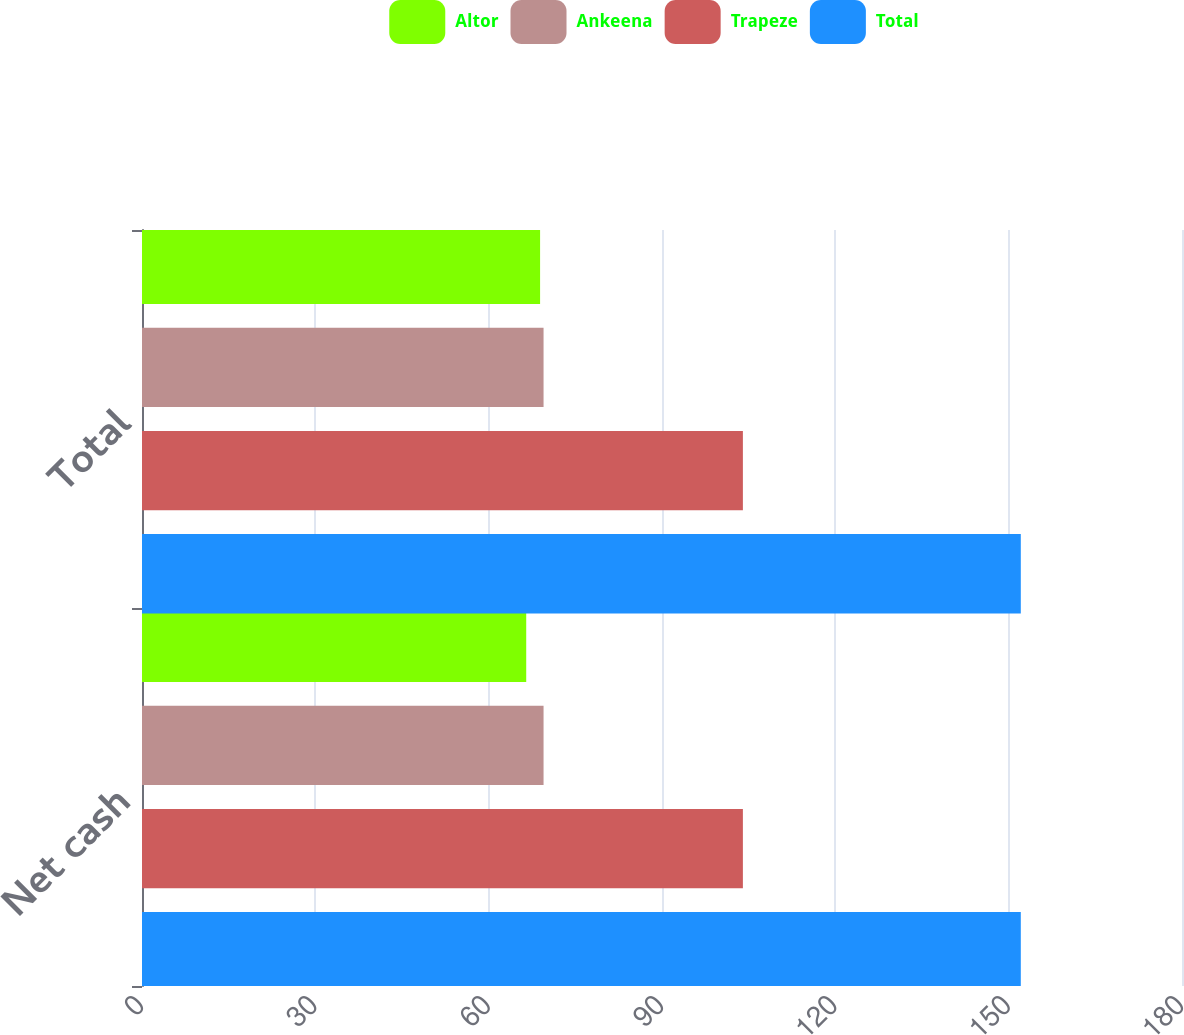Convert chart to OTSL. <chart><loc_0><loc_0><loc_500><loc_500><stacked_bar_chart><ecel><fcel>Net cash<fcel>Total<nl><fcel>Altor<fcel>66.5<fcel>68.9<nl><fcel>Ankeena<fcel>69.5<fcel>69.5<nl><fcel>Trapeze<fcel>104<fcel>104<nl><fcel>Total<fcel>152.1<fcel>152.1<nl></chart> 